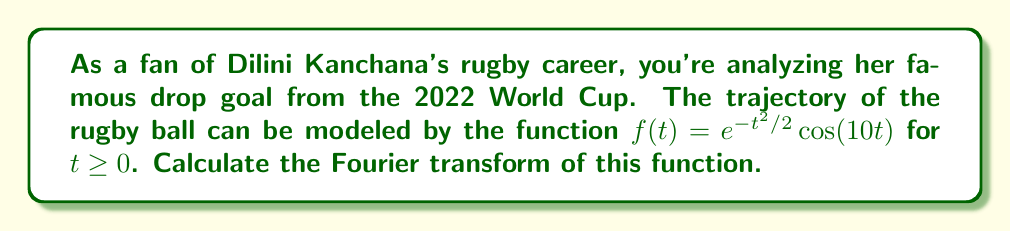Solve this math problem. Let's approach this step-by-step:

1) The Fourier transform of a function $f(t)$ is defined as:

   $$F(\omega) = \int_{-\infty}^{\infty} f(t) e^{-i\omega t} dt$$

2) In our case, $f(t) = e^{-t^2/2}\cos(10t)$ for $t \geq 0$, and $f(t) = 0$ for $t < 0$. So we can write:

   $$F(\omega) = \int_{0}^{\infty} e^{-t^2/2}\cos(10t) e^{-i\omega t} dt$$

3) Using Euler's formula, we can write $\cos(10t) = \frac{e^{10it} + e^{-10it}}{2}$. Substituting this:

   $$F(\omega) = \frac{1}{2}\int_{0}^{\infty} e^{-t^2/2}(e^{10it} + e^{-10it}) e^{-i\omega t} dt$$

4) This can be split into two integrals:

   $$F(\omega) = \frac{1}{2}\int_{0}^{\infty} e^{-t^2/2}e^{(10-\omega)it} dt + \frac{1}{2}\int_{0}^{\infty} e^{-t^2/2}e^{-(10+\omega)it} dt$$

5) These integrals are of the form $\int_{0}^{\infty} e^{-at^2}e^{ibt} dt$, which has a known solution:

   $$\int_{0}^{\infty} e^{-at^2}e^{ibt} dt = \frac{1}{2}\sqrt{\frac{\pi}{a}}e^{-b^2/4a}$$

6) In our case, $a = 1/2$ and $b = 10-\omega$ for the first integral, and $b = -(10+\omega)$ for the second. Applying this:

   $$F(\omega) = \frac{1}{4}\sqrt{2\pi}e^{-(10-\omega)^2/2} + \frac{1}{4}\sqrt{2\pi}e^{-(10+\omega)^2/2}$$

7) This can be simplified to:

   $$F(\omega) = \frac{\sqrt{2\pi}}{4}(e^{-(10-\omega)^2/2} + e^{-(10+\omega)^2/2})$$

This is the Fourier transform of the given function.
Answer: $$F(\omega) = \frac{\sqrt{2\pi}}{4}(e^{-(10-\omega)^2/2} + e^{-(10+\omega)^2/2})$$ 